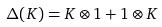<formula> <loc_0><loc_0><loc_500><loc_500>\Delta ( K ) = K \otimes 1 + 1 \otimes K</formula> 